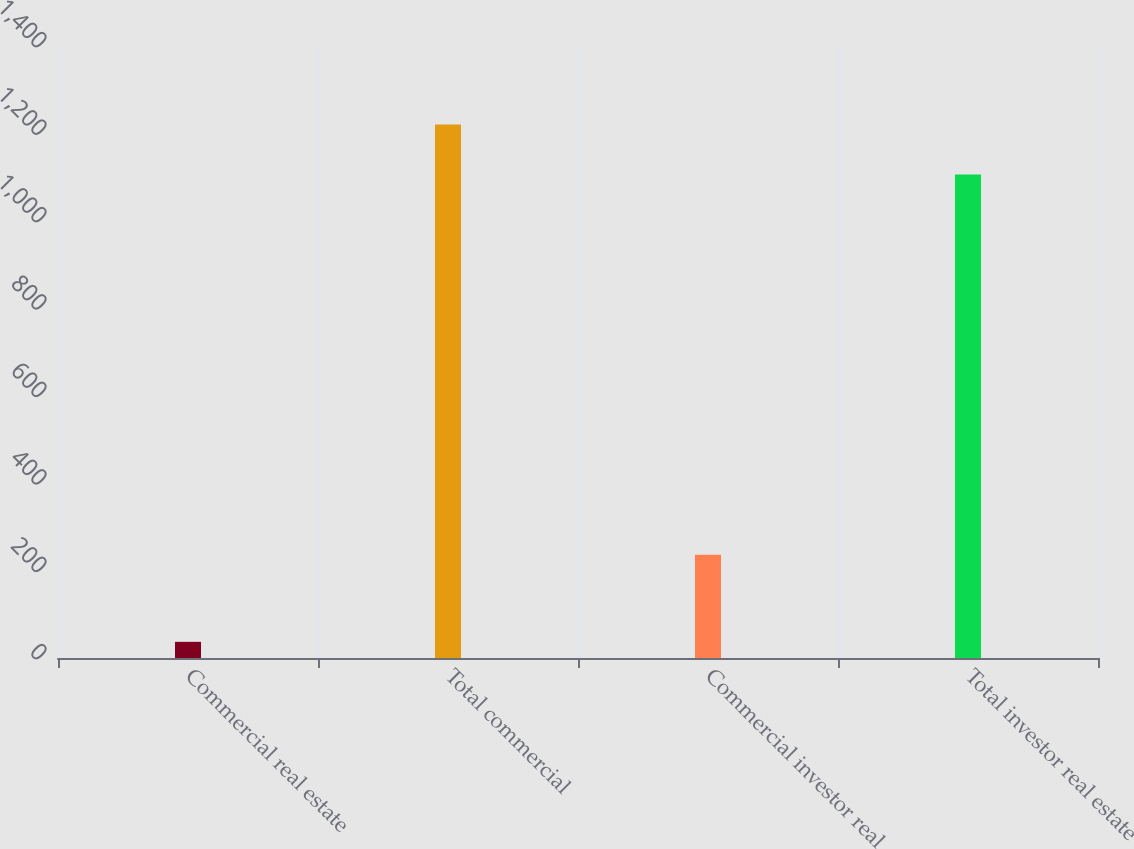Convert chart to OTSL. <chart><loc_0><loc_0><loc_500><loc_500><bar_chart><fcel>Commercial real estate<fcel>Total commercial<fcel>Commercial investor real<fcel>Total investor real estate<nl><fcel>37<fcel>1220.7<fcel>236<fcel>1106<nl></chart> 